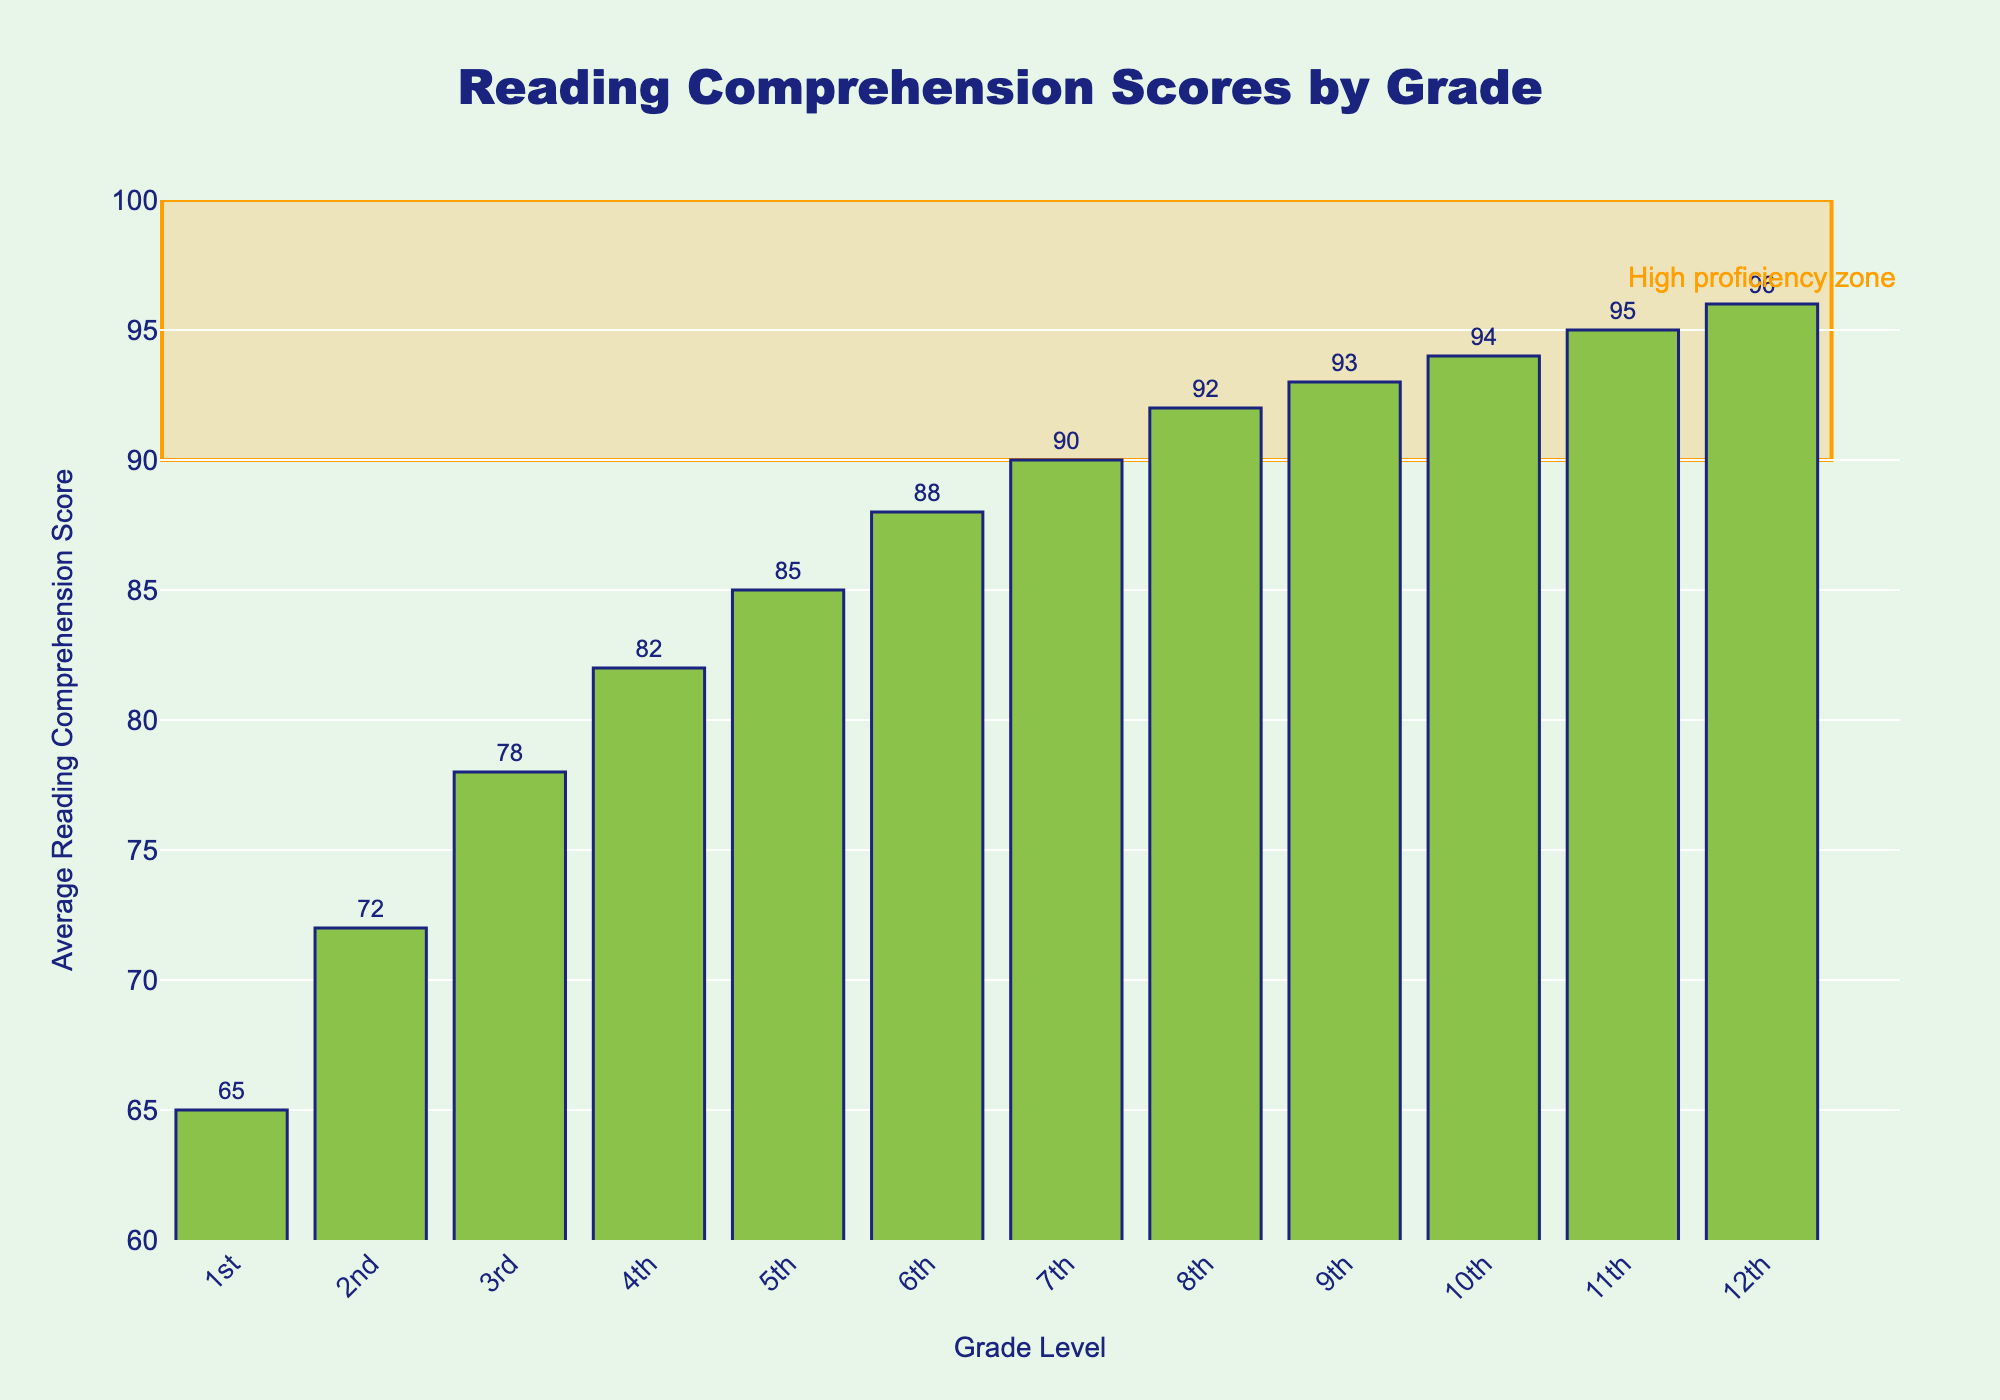What are the reading comprehension scores in 3rd and 7th grades? Look at the bar heights for the 3rd and 7th grades, which are labeled with their scores. The 3rd grade score is 78 and the 7th grade score is 90.
Answer: 78 and 90 Which grade has the highest average reading comprehension score? Identify the tallest bar in the chart, which represents the highest score. The tallest bar is for the 12th grade with a score of 96.
Answer: 12th grade What is the difference in reading comprehension scores between 4th and 6th grades? Find the scores for the 4th and 6th grades: 82 and 88, respectively. Subtract the 4th grade score from the 6th grade score: 88 - 82.
Answer: 6 Which grades fall into the "High proficiency zone"? The "High proficiency zone" is highlighted visually from scores 90 to 100. The grades within this range are 7th to 12th.
Answer: 7th to 12th grades What is the average reading comprehension score across all grades? Sum all reading comprehension scores: (65 + 72 + 78 + 82 + 85 + 88 + 90 + 92 + 93 + 94 + 95 + 96) = 1020. There are 12 grades, so divide the total by 12: 1020 / 12.
Answer: 85 What is the score range from the lowest to the highest grade shown? Identify the lowest and highest scores: 1st grade (65) and 12th grade (96). The range is calculated by subtracting the lowest score from the highest: 96 - 65.
Answer: 31 Which grades have reading comprehension scores greater than 85? Look for bars with scores above 85. These are 6th (88), 7th (90), 8th (92), 9th (93), 10th (94), 11th (95), and 12th (96).
Answer: 6th to 12th grades How many grades have scores less than 80? Count the grades whose scores are below 80. These grades are 1st (65), 2nd (72), and 3rd (78).
Answer: 3 grades Which grade has the least improvement in reading comprehension score compared to the previous grade? Calculate the differences between consecutive grades. The smallest difference is between 9th (93) and 10th (94) with a difference of 1.
Answer: 10th grade 